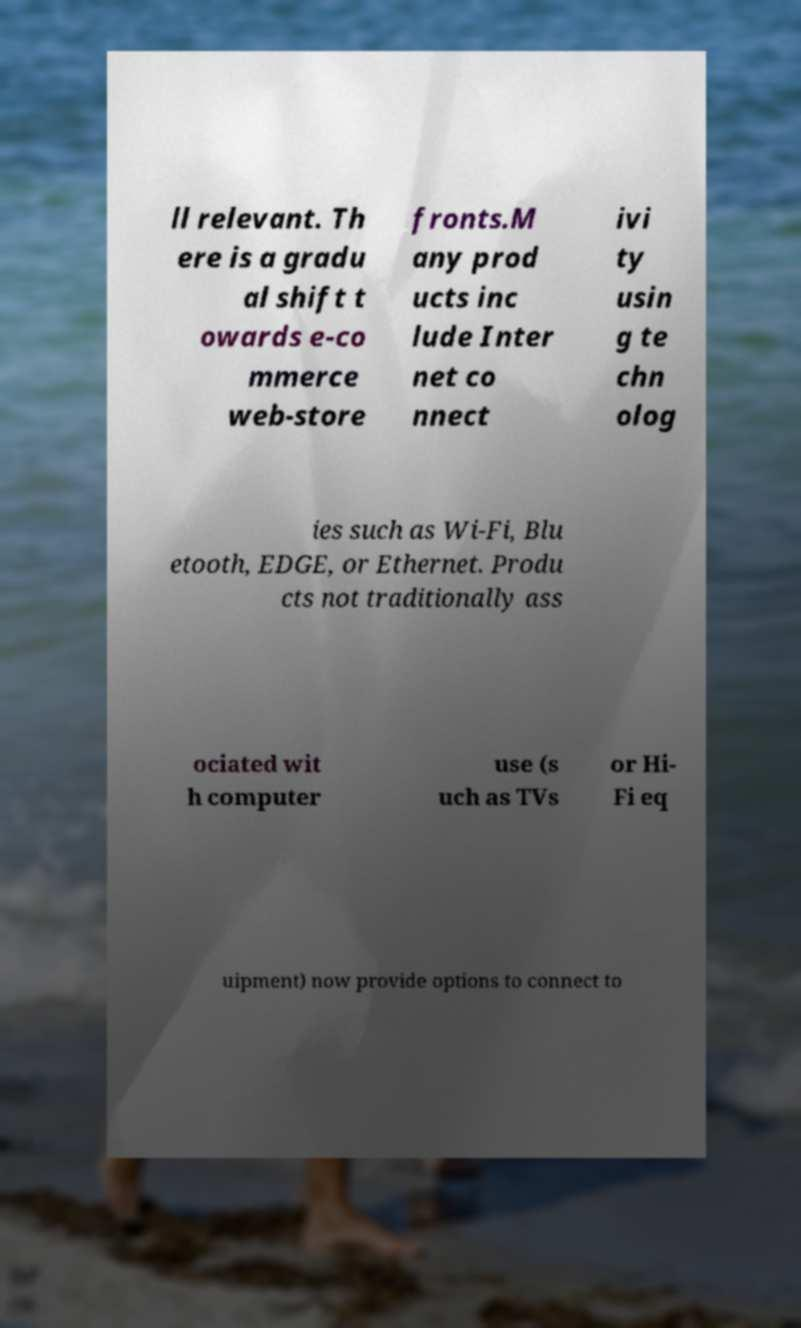Can you accurately transcribe the text from the provided image for me? ll relevant. Th ere is a gradu al shift t owards e-co mmerce web-store fronts.M any prod ucts inc lude Inter net co nnect ivi ty usin g te chn olog ies such as Wi-Fi, Blu etooth, EDGE, or Ethernet. Produ cts not traditionally ass ociated wit h computer use (s uch as TVs or Hi- Fi eq uipment) now provide options to connect to 